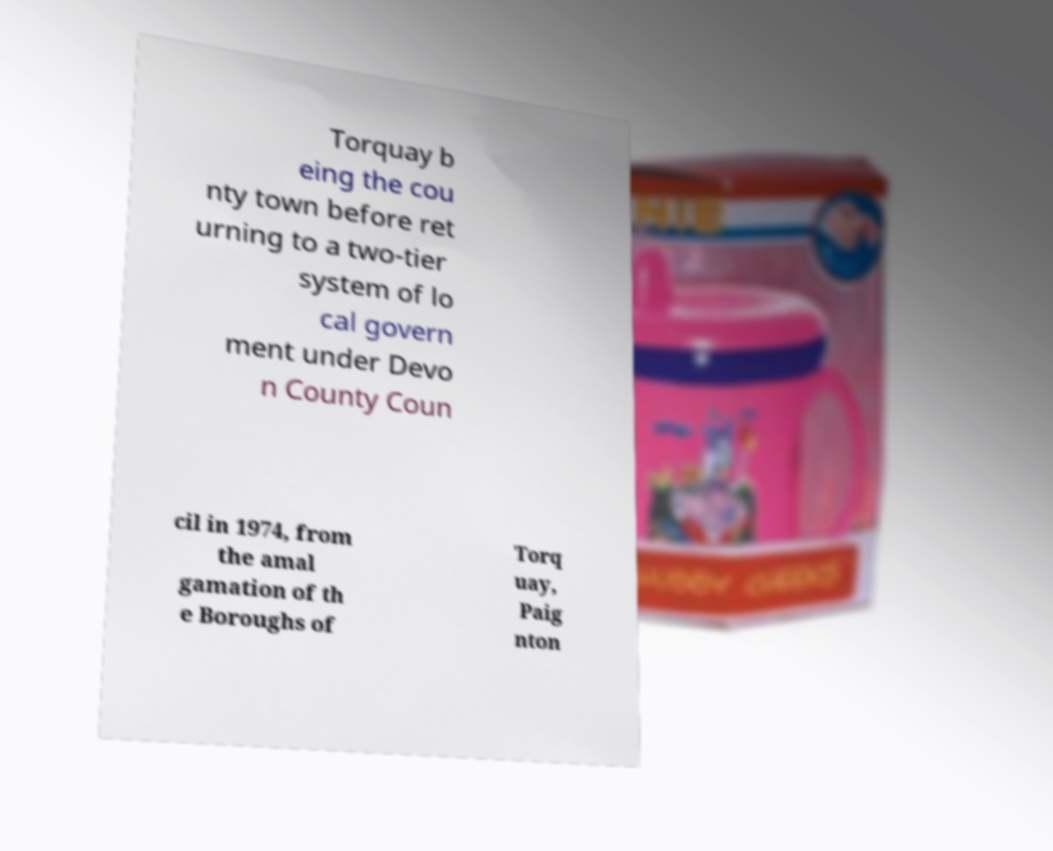For documentation purposes, I need the text within this image transcribed. Could you provide that? Torquay b eing the cou nty town before ret urning to a two-tier system of lo cal govern ment under Devo n County Coun cil in 1974, from the amal gamation of th e Boroughs of Torq uay, Paig nton 